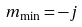Convert formula to latex. <formula><loc_0><loc_0><loc_500><loc_500>m _ { \min } = - j</formula> 